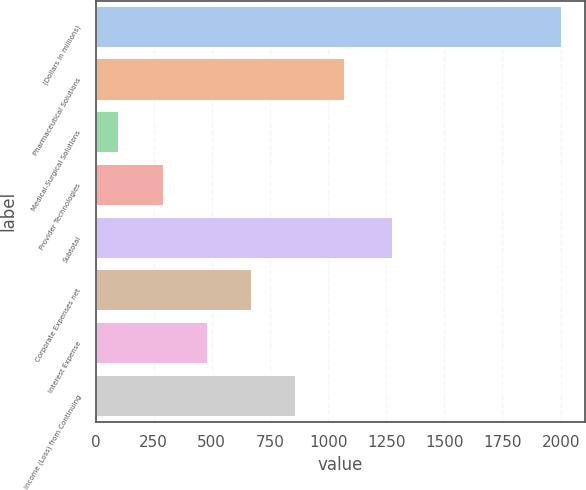Convert chart. <chart><loc_0><loc_0><loc_500><loc_500><bar_chart><fcel>(Dollars in millions)<fcel>Pharmaceutical Solutions<fcel>Medical-Surgical Solutions<fcel>Provider Technologies<fcel>Subtotal<fcel>Corporate Expenses net<fcel>Interest Expense<fcel>Income (Loss) from Continuing<nl><fcel>2005<fcel>1071<fcel>102<fcel>292.3<fcel>1280<fcel>672.9<fcel>482.6<fcel>863.2<nl></chart> 